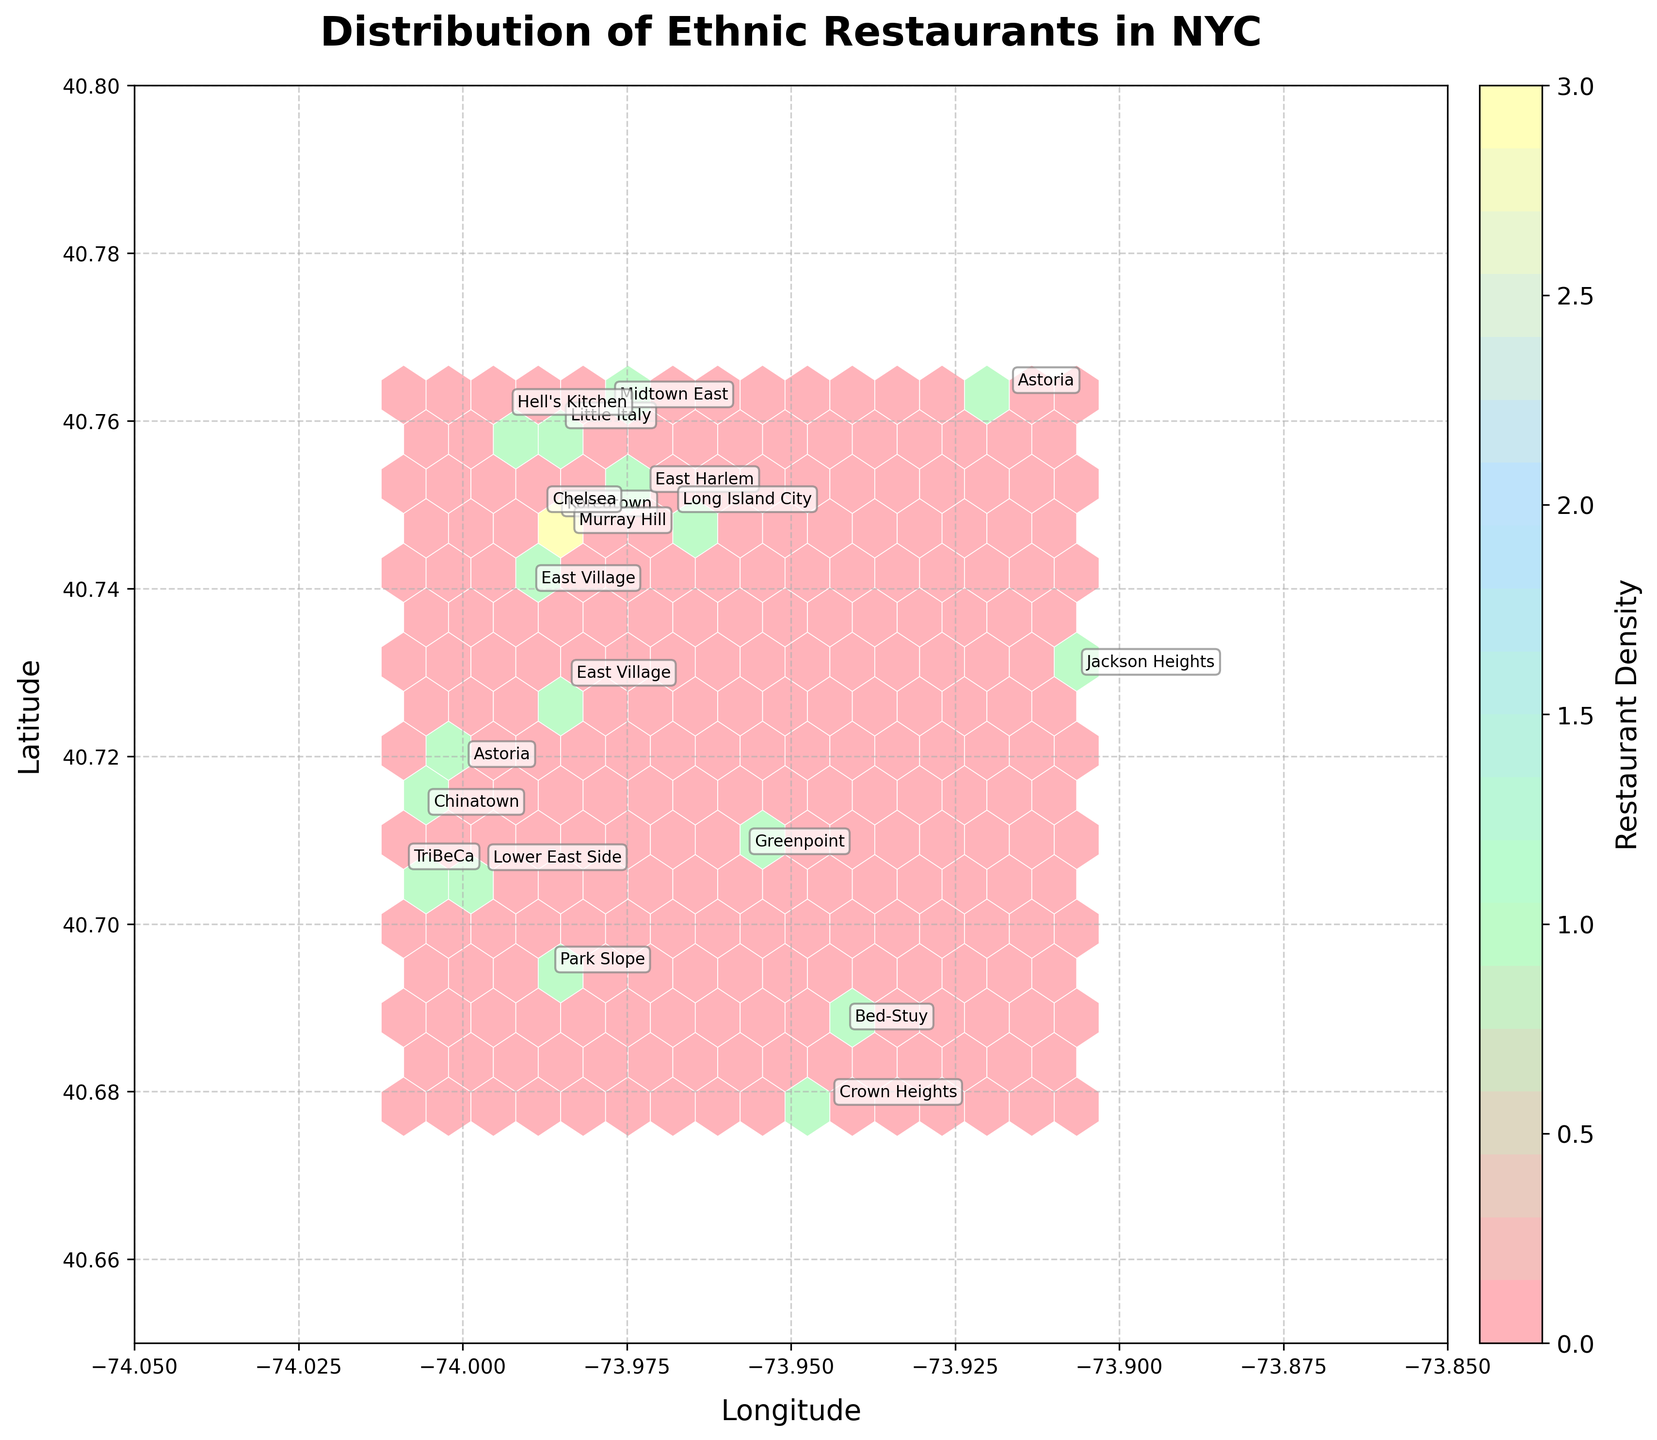What is the title of the hexbin plot? The title of the hexbin plot can be found at the top of the figure. It provides a summary of what the plot is about.
Answer: Distribution of Ethnic Restaurants in NYC What is the color that represents the highest restaurant density in the hexbin plot? The hexbin plot uses different colors to represent densities. The color bar on the side indicates that the highest density is represented by the darkest color.
Answer: A shade of yellow How many neighborhoods are explicitly annotated in the hexbin plot? Each annotated neighborhood has a label on the plot. By counting these labels, we can determine the number of neighborhoods.
Answer: 19 Which neighborhood is located at the southernmost part of the plot? To find the southernmost neighborhood, look for the lowest latitude value annotated on the plot.
Answer: TriBeCa Which neighborhood is depicted the closest to the central point of the Hexbin plot? The central point can be approximated around the average values of the latitude and longitude. The neighborhood label closest to this point will be the answer.
Answer: East Village Do any neighborhoods have more than one restaurant type annotated? To answer this, look at the annotations for neighborhoods. If a neighborhood has multiple labels, it has more than one restaurant type.
Answer: Astoria and East Village What is the trend of the restaurant density from east to west in the Hexbin plot? Observe the color gradient from the right side (east) to the left side (west) of the plot.
Answer: Density decreases from east to west Which ethnic restaurant type is annotated furthest to the north in the hexbin plot? Identify the highest latitude value annotated, and check the restaurant type associated with it.
Answer: Greek Are there any ethnic restaurant types that are uniquely found in a single neighborhood? Look through the labels and identify any restaurant types that appear only once on the plot.
Answer: Multiple types, like Colombian in Jackson Heights What is the approximate longitude range covered by the plotted data? Check the plot's x-axis to note the range of longitudes covered by the data points.
Answer: Approximately -74.05 to -73.85 